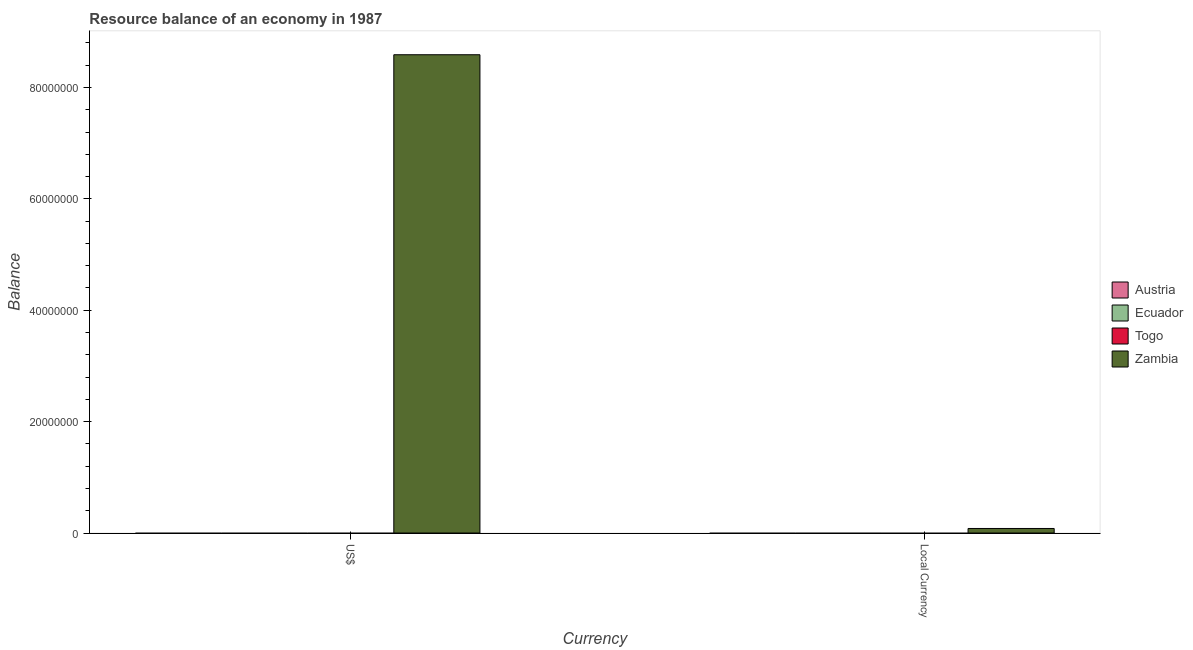How many different coloured bars are there?
Provide a short and direct response. 1. How many bars are there on the 1st tick from the left?
Make the answer very short. 1. How many bars are there on the 2nd tick from the right?
Your answer should be compact. 1. What is the label of the 2nd group of bars from the left?
Offer a very short reply. Local Currency. Across all countries, what is the maximum resource balance in constant us$?
Provide a succinct answer. 8.18e+05. In which country was the resource balance in constant us$ maximum?
Keep it short and to the point. Zambia. What is the total resource balance in constant us$ in the graph?
Keep it short and to the point. 8.18e+05. What is the difference between the resource balance in us$ in Austria and the resource balance in constant us$ in Togo?
Your response must be concise. 0. What is the average resource balance in us$ per country?
Your answer should be compact. 2.15e+07. What is the difference between the resource balance in constant us$ and resource balance in us$ in Zambia?
Provide a succinct answer. -8.51e+07. In how many countries, is the resource balance in us$ greater than 36000000 units?
Provide a short and direct response. 1. In how many countries, is the resource balance in constant us$ greater than the average resource balance in constant us$ taken over all countries?
Offer a terse response. 1. Are all the bars in the graph horizontal?
Ensure brevity in your answer.  No. How many countries are there in the graph?
Your answer should be compact. 4. How many legend labels are there?
Offer a very short reply. 4. What is the title of the graph?
Keep it short and to the point. Resource balance of an economy in 1987. What is the label or title of the X-axis?
Provide a succinct answer. Currency. What is the label or title of the Y-axis?
Offer a terse response. Balance. What is the Balance in Ecuador in US$?
Keep it short and to the point. 0. What is the Balance of Togo in US$?
Give a very brief answer. 0. What is the Balance of Zambia in US$?
Your answer should be very brief. 8.59e+07. What is the Balance of Austria in Local Currency?
Ensure brevity in your answer.  0. What is the Balance of Ecuador in Local Currency?
Ensure brevity in your answer.  0. What is the Balance in Zambia in Local Currency?
Keep it short and to the point. 8.18e+05. Across all Currency, what is the maximum Balance of Zambia?
Keep it short and to the point. 8.59e+07. Across all Currency, what is the minimum Balance in Zambia?
Make the answer very short. 8.18e+05. What is the total Balance in Ecuador in the graph?
Give a very brief answer. 0. What is the total Balance of Zambia in the graph?
Your response must be concise. 8.67e+07. What is the difference between the Balance in Zambia in US$ and that in Local Currency?
Provide a succinct answer. 8.51e+07. What is the average Balance in Austria per Currency?
Make the answer very short. 0. What is the average Balance in Zambia per Currency?
Offer a terse response. 4.33e+07. What is the ratio of the Balance in Zambia in US$ to that in Local Currency?
Give a very brief answer. 105.05. What is the difference between the highest and the second highest Balance of Zambia?
Your response must be concise. 8.51e+07. What is the difference between the highest and the lowest Balance of Zambia?
Your answer should be compact. 8.51e+07. 